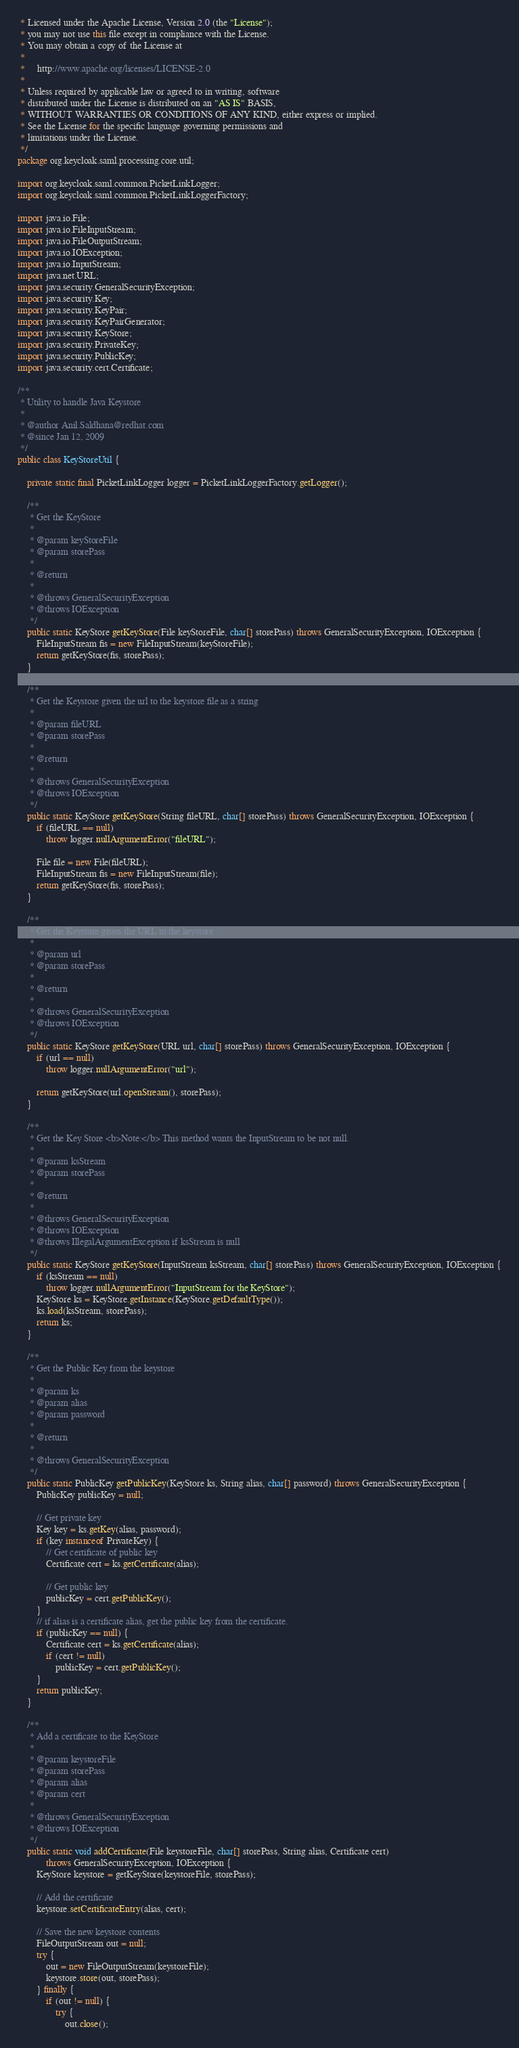<code> <loc_0><loc_0><loc_500><loc_500><_Java_> * Licensed under the Apache License, Version 2.0 (the "License");
 * you may not use this file except in compliance with the License.
 * You may obtain a copy of the License at
 *
 *     http://www.apache.org/licenses/LICENSE-2.0
 *
 * Unless required by applicable law or agreed to in writing, software
 * distributed under the License is distributed on an "AS IS" BASIS,
 * WITHOUT WARRANTIES OR CONDITIONS OF ANY KIND, either express or implied.
 * See the License for the specific language governing permissions and
 * limitations under the License.
 */
package org.keycloak.saml.processing.core.util;

import org.keycloak.saml.common.PicketLinkLogger;
import org.keycloak.saml.common.PicketLinkLoggerFactory;

import java.io.File;
import java.io.FileInputStream;
import java.io.FileOutputStream;
import java.io.IOException;
import java.io.InputStream;
import java.net.URL;
import java.security.GeneralSecurityException;
import java.security.Key;
import java.security.KeyPair;
import java.security.KeyPairGenerator;
import java.security.KeyStore;
import java.security.PrivateKey;
import java.security.PublicKey;
import java.security.cert.Certificate;

/**
 * Utility to handle Java Keystore
 *
 * @author Anil.Saldhana@redhat.com
 * @since Jan 12, 2009
 */
public class KeyStoreUtil {

    private static final PicketLinkLogger logger = PicketLinkLoggerFactory.getLogger();

    /**
     * Get the KeyStore
     *
     * @param keyStoreFile
     * @param storePass
     *
     * @return
     *
     * @throws GeneralSecurityException
     * @throws IOException
     */
    public static KeyStore getKeyStore(File keyStoreFile, char[] storePass) throws GeneralSecurityException, IOException {
        FileInputStream fis = new FileInputStream(keyStoreFile);
        return getKeyStore(fis, storePass);
    }

    /**
     * Get the Keystore given the url to the keystore file as a string
     *
     * @param fileURL
     * @param storePass
     *
     * @return
     *
     * @throws GeneralSecurityException
     * @throws IOException
     */
    public static KeyStore getKeyStore(String fileURL, char[] storePass) throws GeneralSecurityException, IOException {
        if (fileURL == null)
            throw logger.nullArgumentError("fileURL");

        File file = new File(fileURL);
        FileInputStream fis = new FileInputStream(file);
        return getKeyStore(fis, storePass);
    }

    /**
     * Get the Keystore given the URL to the keystore
     *
     * @param url
     * @param storePass
     *
     * @return
     *
     * @throws GeneralSecurityException
     * @throws IOException
     */
    public static KeyStore getKeyStore(URL url, char[] storePass) throws GeneralSecurityException, IOException {
        if (url == null)
            throw logger.nullArgumentError("url");

        return getKeyStore(url.openStream(), storePass);
    }

    /**
     * Get the Key Store <b>Note:</b> This method wants the InputStream to be not null.
     *
     * @param ksStream
     * @param storePass
     *
     * @return
     *
     * @throws GeneralSecurityException
     * @throws IOException
     * @throws IllegalArgumentException if ksStream is null
     */
    public static KeyStore getKeyStore(InputStream ksStream, char[] storePass) throws GeneralSecurityException, IOException {
        if (ksStream == null)
            throw logger.nullArgumentError("InputStream for the KeyStore");
        KeyStore ks = KeyStore.getInstance(KeyStore.getDefaultType());
        ks.load(ksStream, storePass);
        return ks;
    }

    /**
     * Get the Public Key from the keystore
     *
     * @param ks
     * @param alias
     * @param password
     *
     * @return
     *
     * @throws GeneralSecurityException
     */
    public static PublicKey getPublicKey(KeyStore ks, String alias, char[] password) throws GeneralSecurityException {
        PublicKey publicKey = null;

        // Get private key
        Key key = ks.getKey(alias, password);
        if (key instanceof PrivateKey) {
            // Get certificate of public key
            Certificate cert = ks.getCertificate(alias);

            // Get public key
            publicKey = cert.getPublicKey();
        }
        // if alias is a certificate alias, get the public key from the certificate.
        if (publicKey == null) {
            Certificate cert = ks.getCertificate(alias);
            if (cert != null)
                publicKey = cert.getPublicKey();
        }
        return publicKey;
    }

    /**
     * Add a certificate to the KeyStore
     *
     * @param keystoreFile
     * @param storePass
     * @param alias
     * @param cert
     *
     * @throws GeneralSecurityException
     * @throws IOException
     */
    public static void addCertificate(File keystoreFile, char[] storePass, String alias, Certificate cert)
            throws GeneralSecurityException, IOException {
        KeyStore keystore = getKeyStore(keystoreFile, storePass);

        // Add the certificate
        keystore.setCertificateEntry(alias, cert);

        // Save the new keystore contents
        FileOutputStream out = null;
        try {
            out = new FileOutputStream(keystoreFile);
            keystore.store(out, storePass);
        } finally {
            if (out != null) {
                try {
                    out.close();</code> 